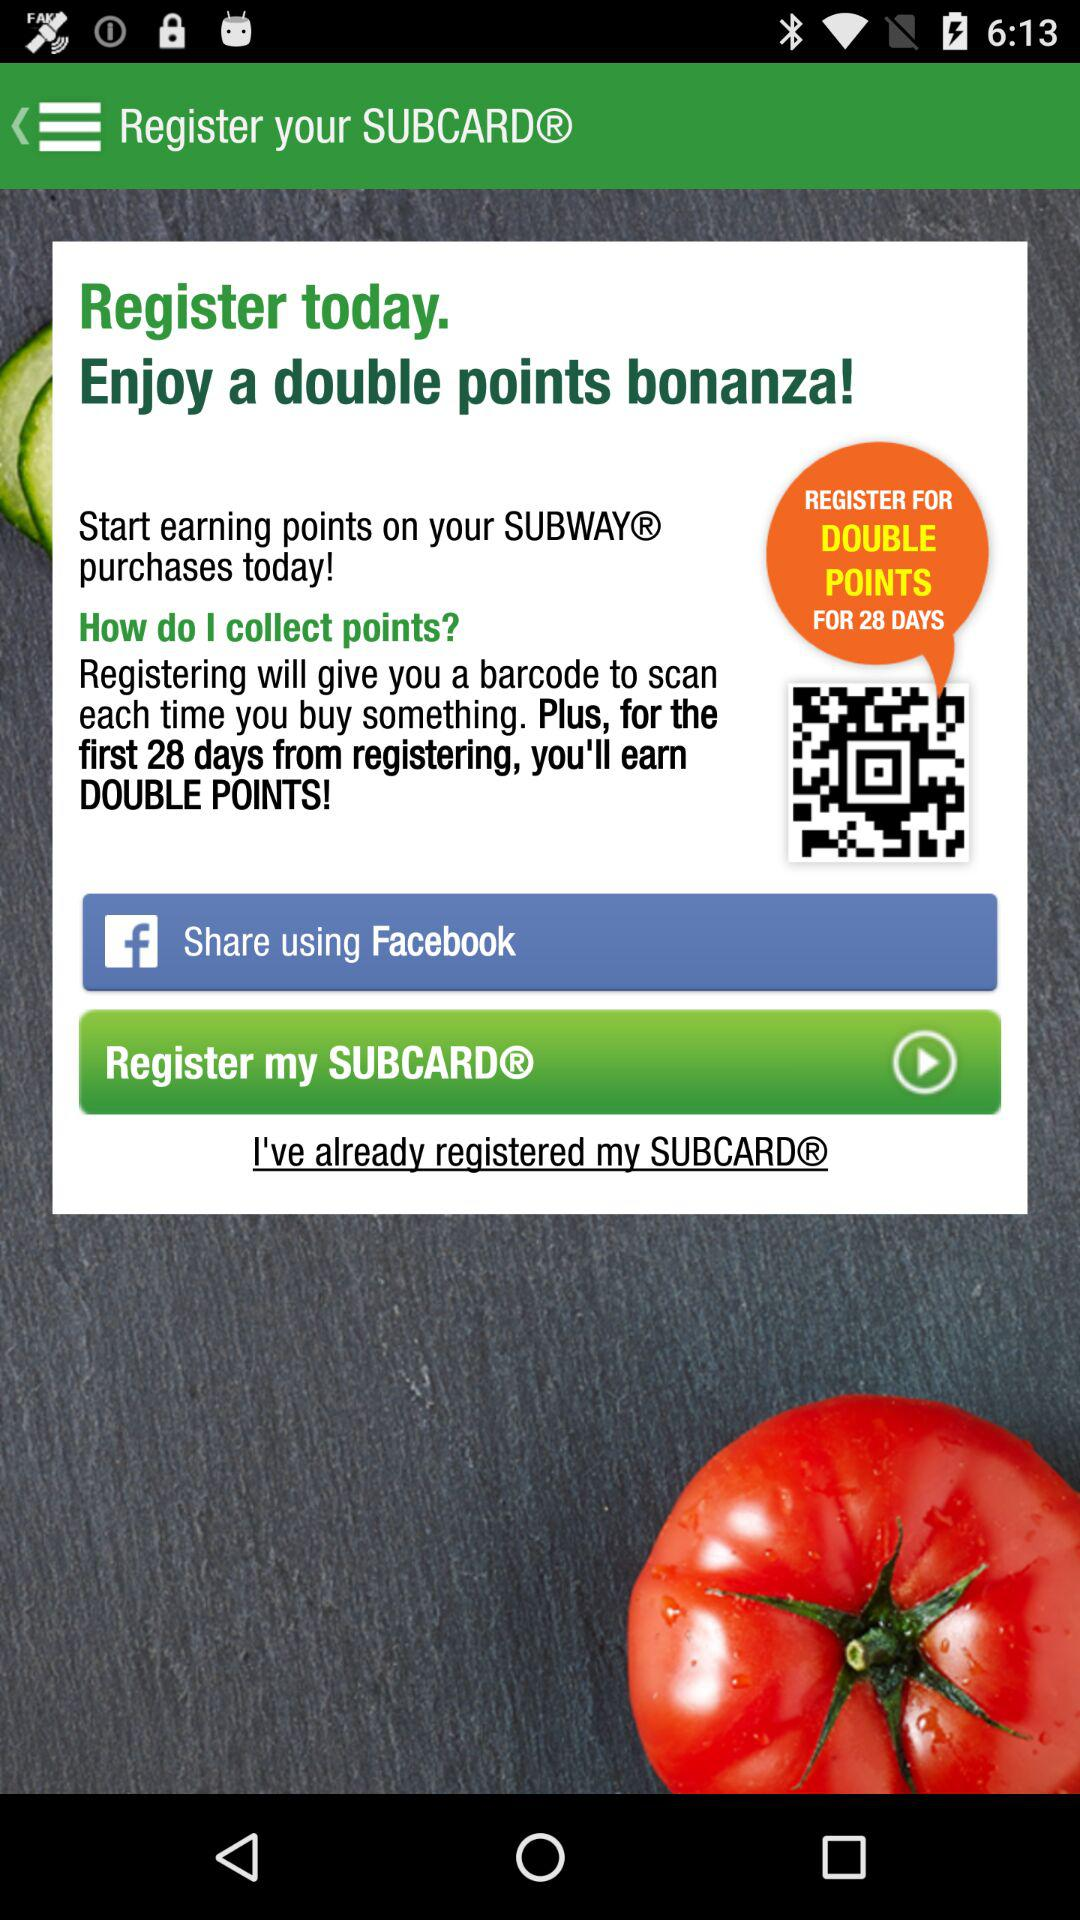What's the time period for earning double points? The time period for earning double points is 28 days from registration. 